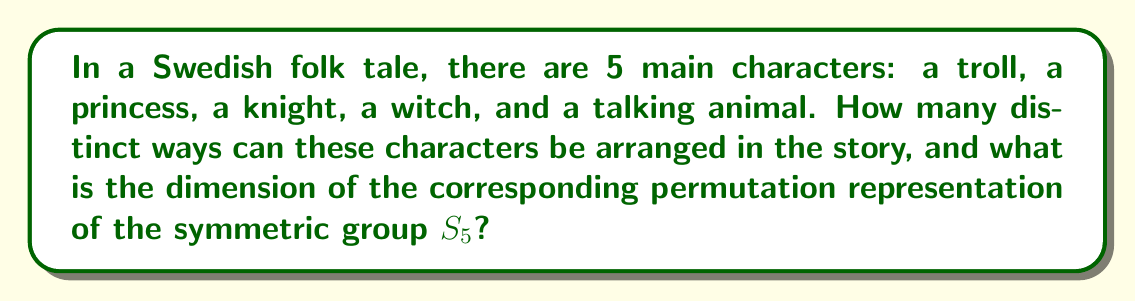Provide a solution to this math problem. Let's approach this step-by-step:

1) First, we need to understand that the number of ways to arrange 5 distinct characters is equal to the number of permutations of 5 elements, which is 5!.

   $5! = 5 \times 4 \times 3 \times 2 \times 1 = 120$

2) In representation theory, this corresponds to the regular representation of the symmetric group $S_5$.

3) The dimension of a representation is equal to the dimension of the vector space on which the group acts. In this case, the group $S_5$ acts on a vector space with basis vectors corresponding to each permutation.

4) Therefore, the dimension of this permutation representation is equal to the number of permutations, which is 120.

5) In the language of representation theory, we can express this as:

   $$\dim(R_{S_5}) = |S_5| = 5! = 120$$

   where $R_{S_5}$ denotes the regular representation of $S_5$.

6) It's worth noting that this representation is reducible and can be decomposed into irreducible representations, each corresponding to a partition of 5. However, that decomposition is beyond the scope of this specific question.
Answer: 120 